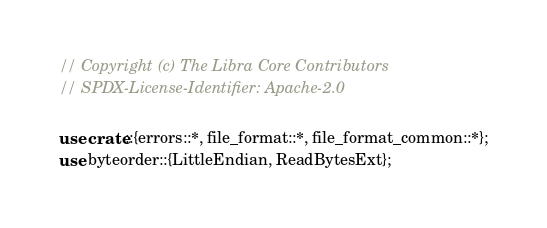Convert code to text. <code><loc_0><loc_0><loc_500><loc_500><_Rust_>// Copyright (c) The Libra Core Contributors
// SPDX-License-Identifier: Apache-2.0

use crate::{errors::*, file_format::*, file_format_common::*};
use byteorder::{LittleEndian, ReadBytesExt};</code> 